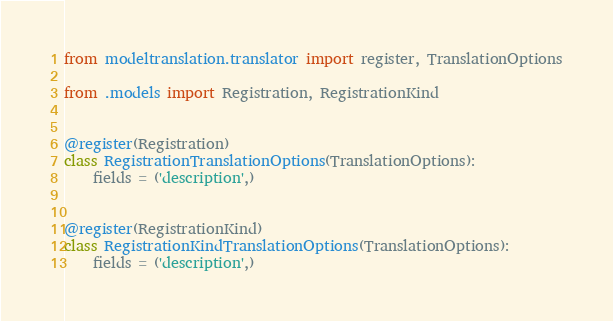<code> <loc_0><loc_0><loc_500><loc_500><_Python_>from modeltranslation.translator import register, TranslationOptions

from .models import Registration, RegistrationKind


@register(Registration)
class RegistrationTranslationOptions(TranslationOptions):
    fields = ('description',)


@register(RegistrationKind)
class RegistrationKindTranslationOptions(TranslationOptions):
    fields = ('description',)
</code> 